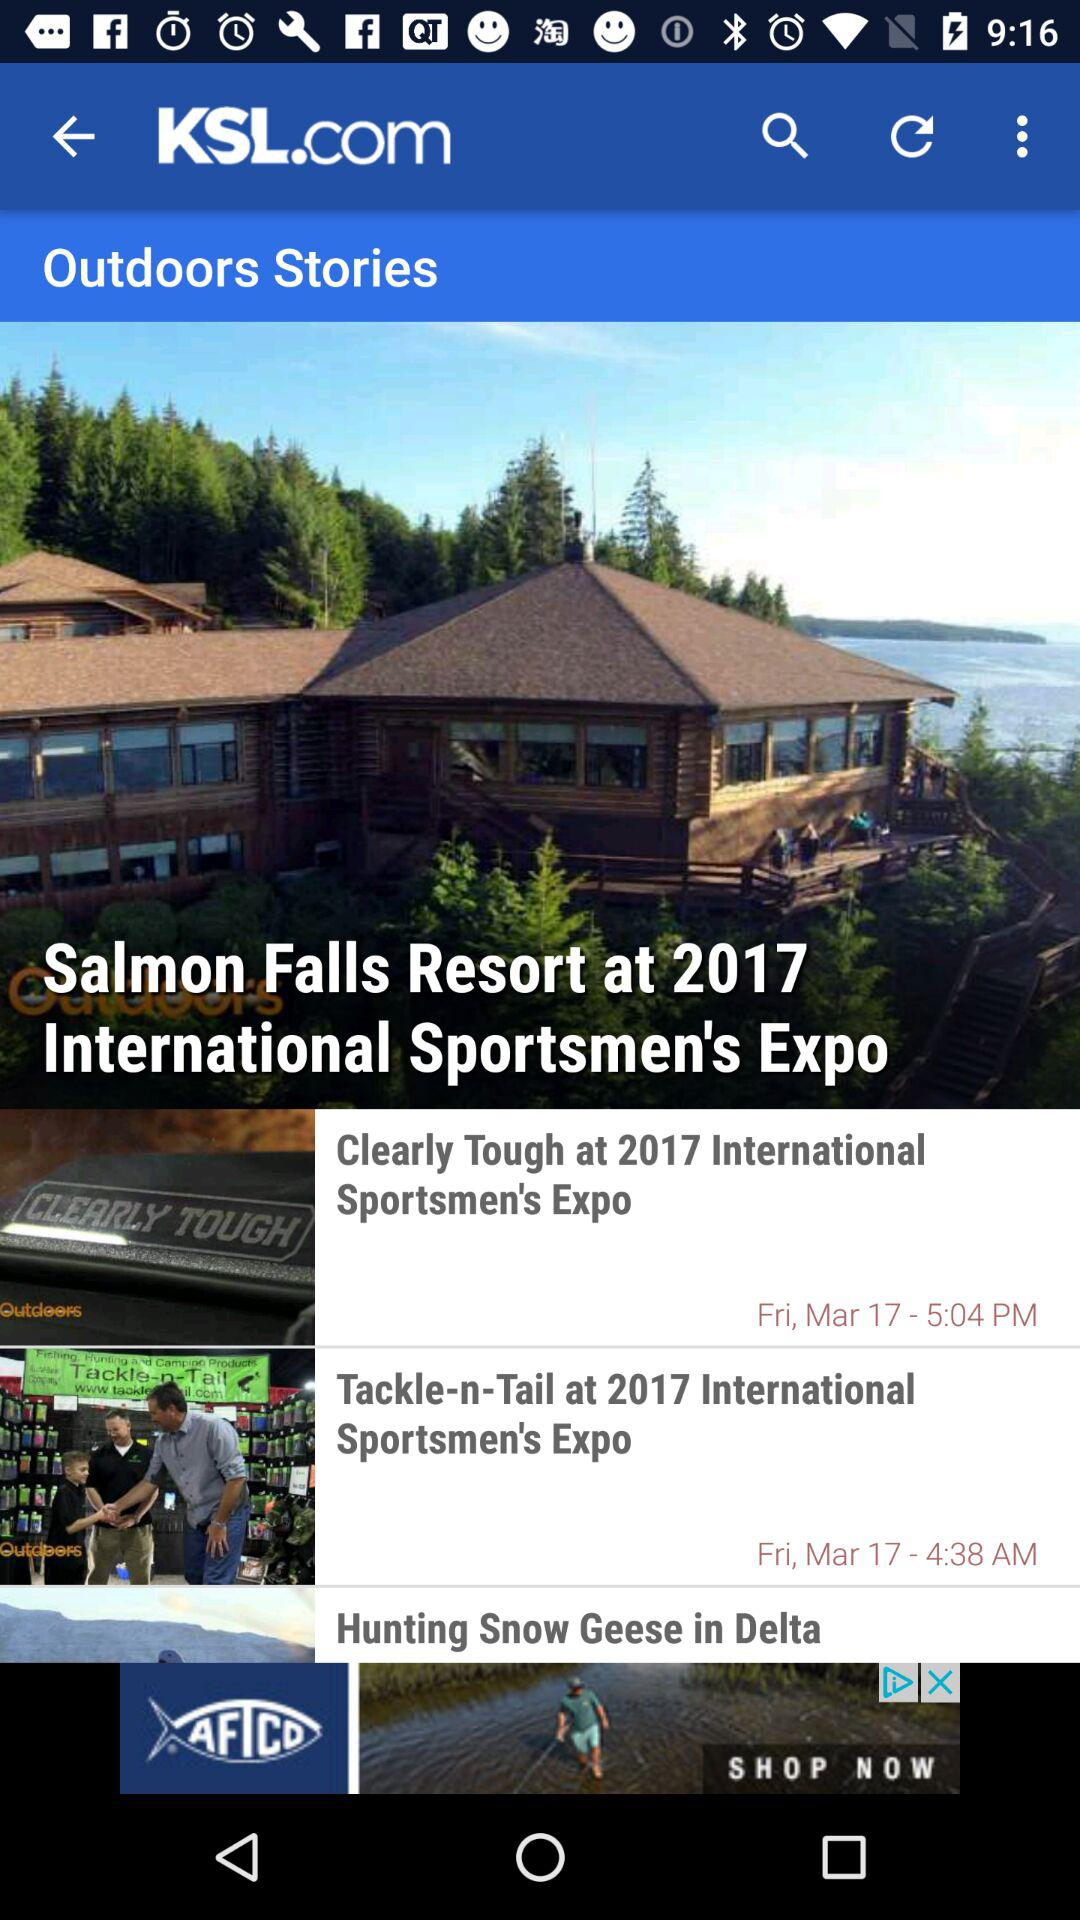On what date was the story "Clearly Tough at 2017 International Sportsmen's Expo" posted? The story "Clearly Tough at 2017 International Sportsmen's Expo" was posted on Friday, 17th March. 